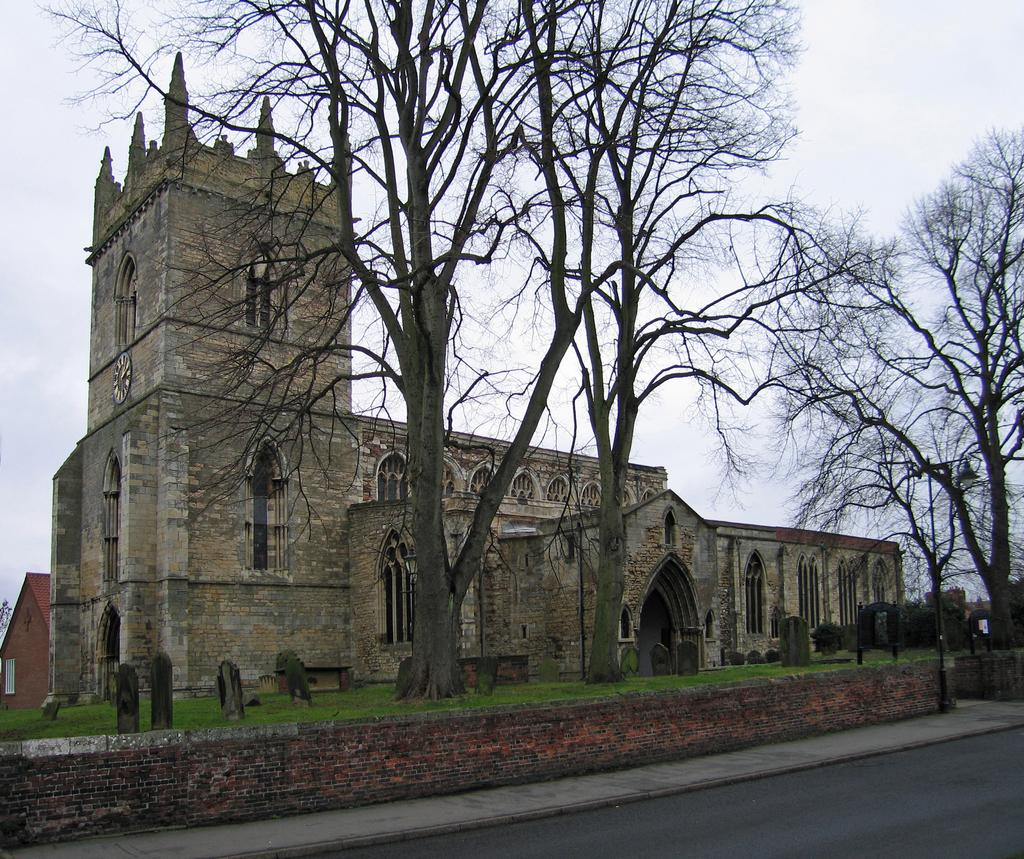What type of building can be seen in the image? There is a church in the image. What other natural elements are present in the image? There are trees and a cloudy sky visible in the image. What man-made structures can be seen in the image? There is a wall and a road visible in the image. What type of ground surface is visible at the bottom of the image? There is a road visible at the bottom of the image. Can you see any yokes being used in the image? There is no yoke present in the image. What type of breakfast is being served in the image? There is no breakfast present in the image. 